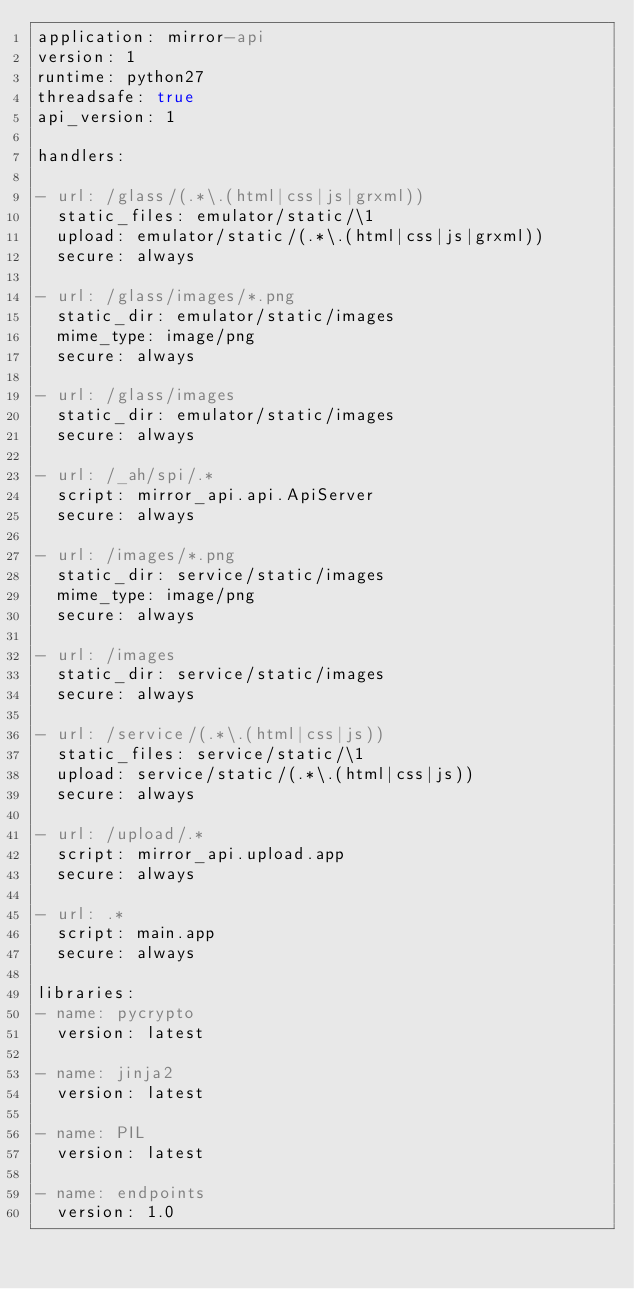<code> <loc_0><loc_0><loc_500><loc_500><_YAML_>application: mirror-api
version: 1
runtime: python27
threadsafe: true
api_version: 1

handlers:

- url: /glass/(.*\.(html|css|js|grxml))
  static_files: emulator/static/\1
  upload: emulator/static/(.*\.(html|css|js|grxml))
  secure: always

- url: /glass/images/*.png
  static_dir: emulator/static/images
  mime_type: image/png
  secure: always

- url: /glass/images
  static_dir: emulator/static/images
  secure: always

- url: /_ah/spi/.*
  script: mirror_api.api.ApiServer
  secure: always

- url: /images/*.png
  static_dir: service/static/images
  mime_type: image/png
  secure: always

- url: /images
  static_dir: service/static/images
  secure: always

- url: /service/(.*\.(html|css|js))
  static_files: service/static/\1
  upload: service/static/(.*\.(html|css|js))
  secure: always

- url: /upload/.*
  script: mirror_api.upload.app
  secure: always

- url: .*
  script: main.app
  secure: always

libraries:
- name: pycrypto
  version: latest

- name: jinja2
  version: latest

- name: PIL
  version: latest

- name: endpoints
  version: 1.0
</code> 